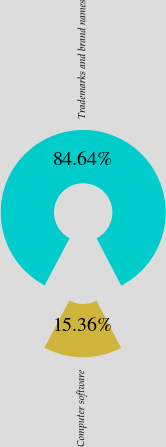<chart> <loc_0><loc_0><loc_500><loc_500><pie_chart><fcel>Trademarks and brand names<fcel>Computer software<nl><fcel>84.64%<fcel>15.36%<nl></chart> 